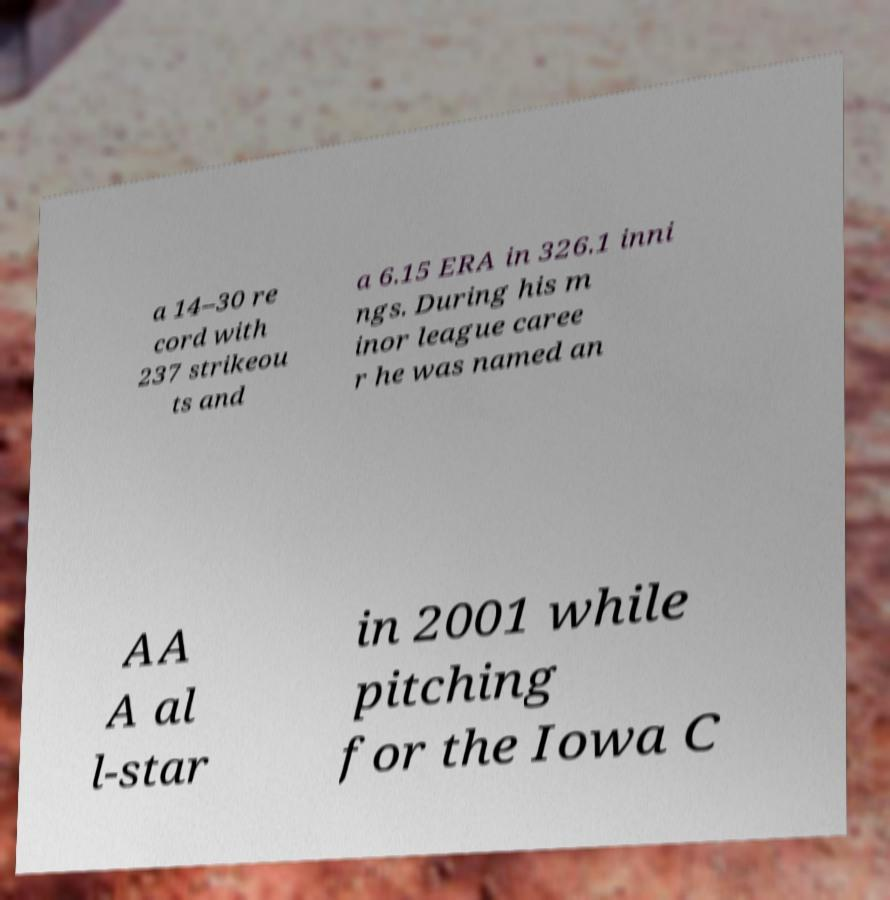Could you extract and type out the text from this image? a 14–30 re cord with 237 strikeou ts and a 6.15 ERA in 326.1 inni ngs. During his m inor league caree r he was named an AA A al l-star in 2001 while pitching for the Iowa C 